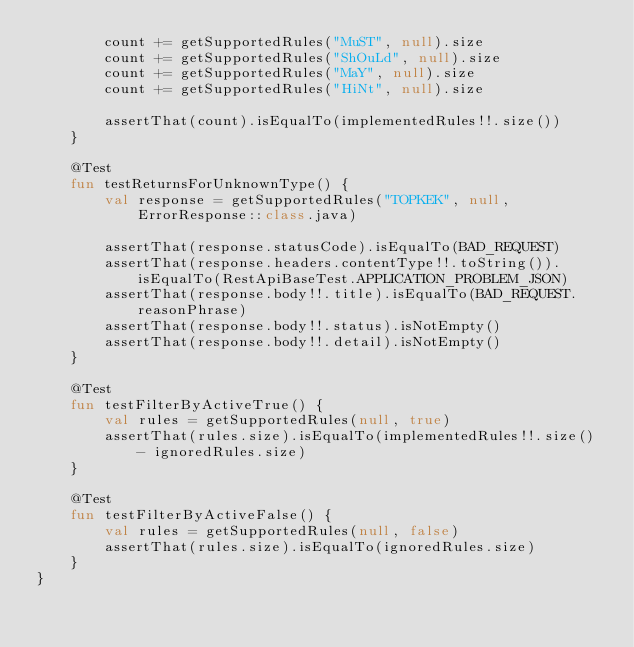<code> <loc_0><loc_0><loc_500><loc_500><_Kotlin_>        count += getSupportedRules("MuST", null).size
        count += getSupportedRules("ShOuLd", null).size
        count += getSupportedRules("MaY", null).size
        count += getSupportedRules("HiNt", null).size

        assertThat(count).isEqualTo(implementedRules!!.size())
    }

    @Test
    fun testReturnsForUnknownType() {
        val response = getSupportedRules("TOPKEK", null, ErrorResponse::class.java)

        assertThat(response.statusCode).isEqualTo(BAD_REQUEST)
        assertThat(response.headers.contentType!!.toString()).isEqualTo(RestApiBaseTest.APPLICATION_PROBLEM_JSON)
        assertThat(response.body!!.title).isEqualTo(BAD_REQUEST.reasonPhrase)
        assertThat(response.body!!.status).isNotEmpty()
        assertThat(response.body!!.detail).isNotEmpty()
    }

    @Test
    fun testFilterByActiveTrue() {
        val rules = getSupportedRules(null, true)
        assertThat(rules.size).isEqualTo(implementedRules!!.size() - ignoredRules.size)
    }

    @Test
    fun testFilterByActiveFalse() {
        val rules = getSupportedRules(null, false)
        assertThat(rules.size).isEqualTo(ignoredRules.size)
    }
}
</code> 